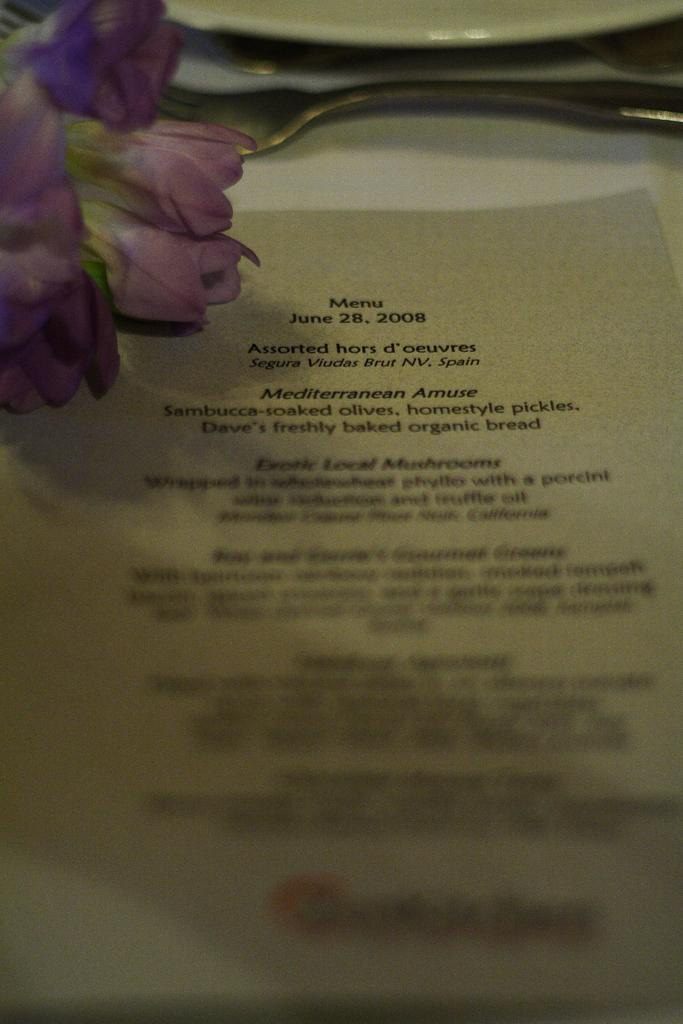What is present in the image that might contain a message or information? There is a letter in the image. Can you describe the letter in the image? The letter has writing on it. What type of floral element can be seen in the image? There is a purple flower in the image. What type of wound can be seen on the letter in the image? There is no wound present on the letter in the image. What scientific theory is being discussed in the image? There is no discussion of a scientific theory in the image; it contains a letter with writing and a purple flower. 